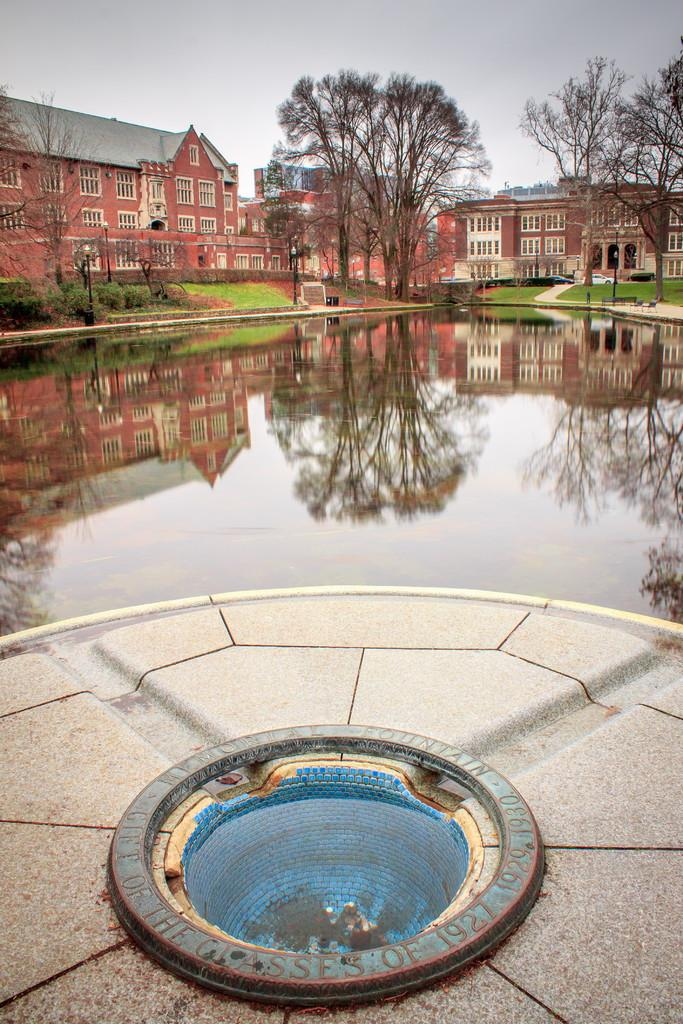What is the main feature in the image? There is a water fountain in the image. What type of structures can be seen in the image? There are buildings with windows in the image. What natural elements are present in the image? There are trees and grass in the image. What man-made objects can be seen in the image? There are cars in the image. What is visible in the background of the image? The sky is visible in the background of the image. Can you see a mountain in the image? There is no mountain present in the image. What type of beast is interacting with the water fountain in the image? There is no beast present in the image; only the water fountain, buildings, trees, grass, cars, and sky are visible. 